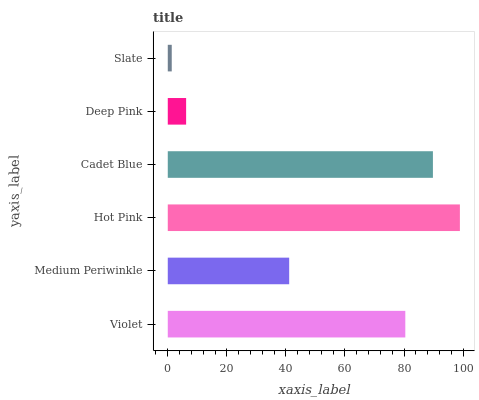Is Slate the minimum?
Answer yes or no. Yes. Is Hot Pink the maximum?
Answer yes or no. Yes. Is Medium Periwinkle the minimum?
Answer yes or no. No. Is Medium Periwinkle the maximum?
Answer yes or no. No. Is Violet greater than Medium Periwinkle?
Answer yes or no. Yes. Is Medium Periwinkle less than Violet?
Answer yes or no. Yes. Is Medium Periwinkle greater than Violet?
Answer yes or no. No. Is Violet less than Medium Periwinkle?
Answer yes or no. No. Is Violet the high median?
Answer yes or no. Yes. Is Medium Periwinkle the low median?
Answer yes or no. Yes. Is Cadet Blue the high median?
Answer yes or no. No. Is Hot Pink the low median?
Answer yes or no. No. 